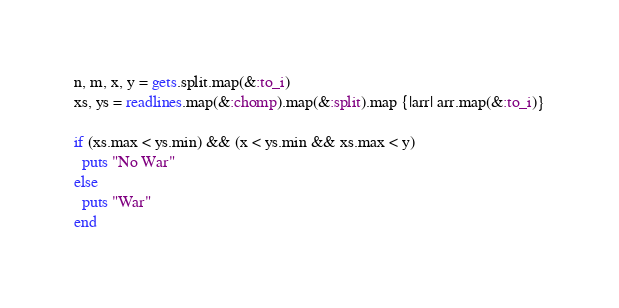Convert code to text. <code><loc_0><loc_0><loc_500><loc_500><_Ruby_>n, m, x, y = gets.split.map(&:to_i)
xs, ys = readlines.map(&:chomp).map(&:split).map {|arr| arr.map(&:to_i)}

if (xs.max < ys.min) && (x < ys.min && xs.max < y)
  puts "No War"
else
  puts "War"
end
</code> 